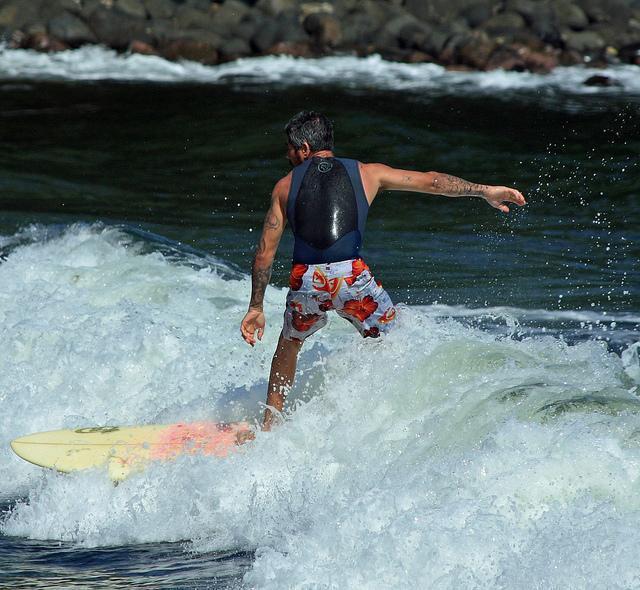How many birds are standing in the pizza box?
Give a very brief answer. 0. 